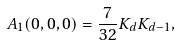Convert formula to latex. <formula><loc_0><loc_0><loc_500><loc_500>A _ { 1 } ( 0 , 0 , 0 ) = \frac { 7 } { 3 2 } K _ { d } K _ { d - 1 } ,</formula> 